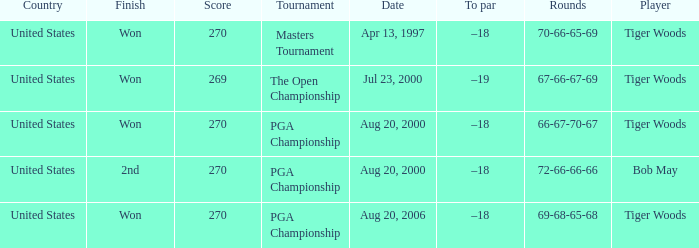What country hosts the tournament the open championship? United States. 